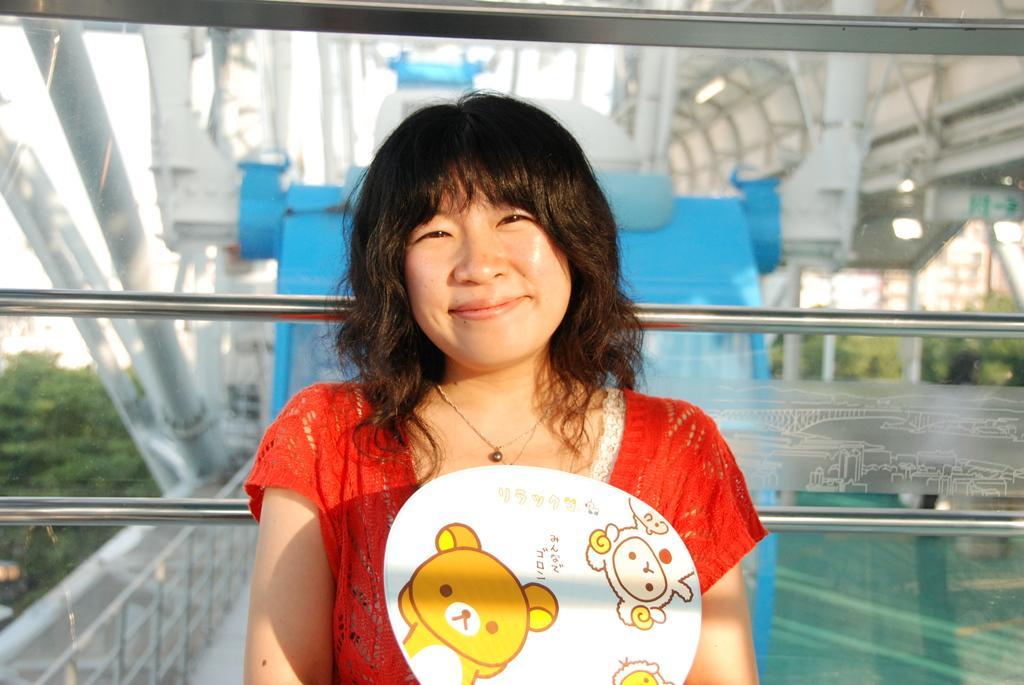In one or two sentences, can you explain what this image depicts? Here we can see a woman and she is smiling. This is glass. From the glass we can see poles, bridge, board, and trees. 